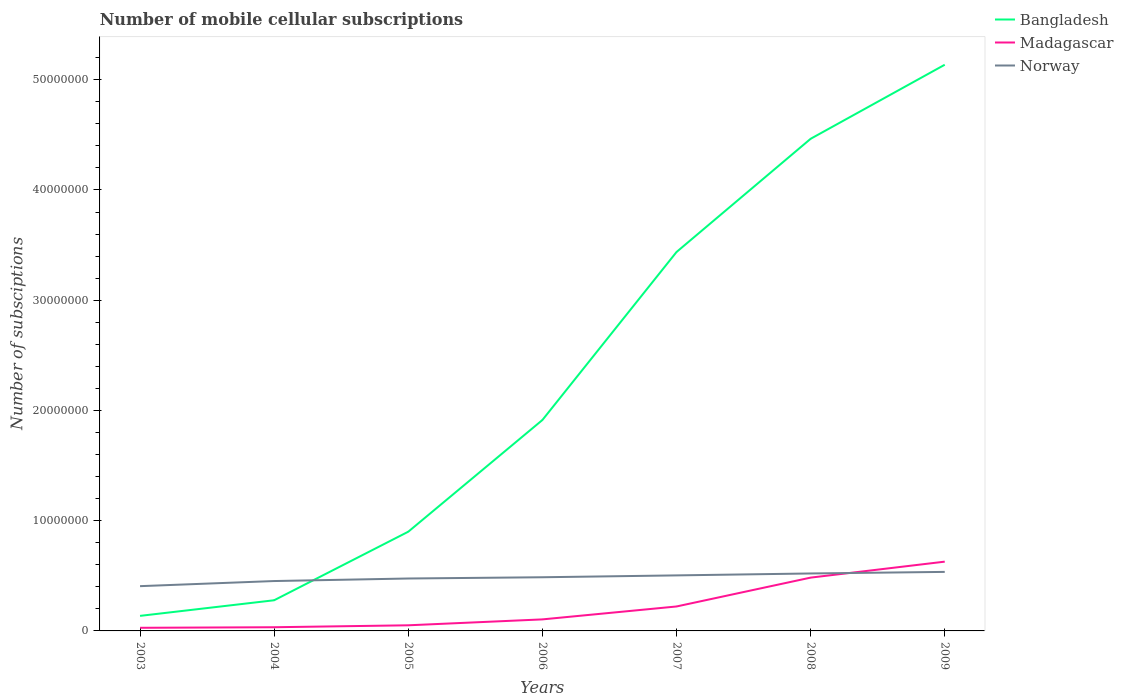Across all years, what is the maximum number of mobile cellular subscriptions in Madagascar?
Give a very brief answer. 2.84e+05. In which year was the number of mobile cellular subscriptions in Norway maximum?
Your response must be concise. 2003. What is the total number of mobile cellular subscriptions in Norway in the graph?
Provide a short and direct response. -4.86e+05. What is the difference between the highest and the second highest number of mobile cellular subscriptions in Madagascar?
Your response must be concise. 6.00e+06. What is the difference between the highest and the lowest number of mobile cellular subscriptions in Bangladesh?
Your answer should be very brief. 3. Is the number of mobile cellular subscriptions in Madagascar strictly greater than the number of mobile cellular subscriptions in Norway over the years?
Make the answer very short. No. How many years are there in the graph?
Give a very brief answer. 7. What is the difference between two consecutive major ticks on the Y-axis?
Your answer should be very brief. 1.00e+07. Does the graph contain any zero values?
Offer a very short reply. No. How are the legend labels stacked?
Ensure brevity in your answer.  Vertical. What is the title of the graph?
Your answer should be very brief. Number of mobile cellular subscriptions. What is the label or title of the X-axis?
Offer a terse response. Years. What is the label or title of the Y-axis?
Provide a short and direct response. Number of subsciptions. What is the Number of subsciptions in Bangladesh in 2003?
Your response must be concise. 1.36e+06. What is the Number of subsciptions of Madagascar in 2003?
Your response must be concise. 2.84e+05. What is the Number of subsciptions in Norway in 2003?
Your answer should be very brief. 4.06e+06. What is the Number of subsciptions of Bangladesh in 2004?
Provide a short and direct response. 2.78e+06. What is the Number of subsciptions in Madagascar in 2004?
Your response must be concise. 3.34e+05. What is the Number of subsciptions of Norway in 2004?
Offer a very short reply. 4.52e+06. What is the Number of subsciptions in Bangladesh in 2005?
Offer a terse response. 9.00e+06. What is the Number of subsciptions of Madagascar in 2005?
Offer a terse response. 5.10e+05. What is the Number of subsciptions of Norway in 2005?
Offer a terse response. 4.75e+06. What is the Number of subsciptions in Bangladesh in 2006?
Provide a succinct answer. 1.91e+07. What is the Number of subsciptions of Madagascar in 2006?
Your response must be concise. 1.05e+06. What is the Number of subsciptions of Norway in 2006?
Your answer should be compact. 4.87e+06. What is the Number of subsciptions in Bangladesh in 2007?
Give a very brief answer. 3.44e+07. What is the Number of subsciptions in Madagascar in 2007?
Your answer should be very brief. 2.22e+06. What is the Number of subsciptions in Norway in 2007?
Provide a succinct answer. 5.04e+06. What is the Number of subsciptions in Bangladesh in 2008?
Offer a very short reply. 4.46e+07. What is the Number of subsciptions of Madagascar in 2008?
Offer a very short reply. 4.84e+06. What is the Number of subsciptions of Norway in 2008?
Offer a terse response. 5.21e+06. What is the Number of subsciptions of Bangladesh in 2009?
Make the answer very short. 5.14e+07. What is the Number of subsciptions of Madagascar in 2009?
Ensure brevity in your answer.  6.28e+06. What is the Number of subsciptions in Norway in 2009?
Keep it short and to the point. 5.35e+06. Across all years, what is the maximum Number of subsciptions of Bangladesh?
Your response must be concise. 5.14e+07. Across all years, what is the maximum Number of subsciptions in Madagascar?
Keep it short and to the point. 6.28e+06. Across all years, what is the maximum Number of subsciptions of Norway?
Make the answer very short. 5.35e+06. Across all years, what is the minimum Number of subsciptions of Bangladesh?
Offer a very short reply. 1.36e+06. Across all years, what is the minimum Number of subsciptions in Madagascar?
Keep it short and to the point. 2.84e+05. Across all years, what is the minimum Number of subsciptions of Norway?
Your answer should be very brief. 4.06e+06. What is the total Number of subsciptions in Bangladesh in the graph?
Provide a short and direct response. 1.63e+08. What is the total Number of subsciptions of Madagascar in the graph?
Make the answer very short. 1.55e+07. What is the total Number of subsciptions in Norway in the graph?
Offer a terse response. 3.38e+07. What is the difference between the Number of subsciptions of Bangladesh in 2003 and that in 2004?
Keep it short and to the point. -1.42e+06. What is the difference between the Number of subsciptions of Madagascar in 2003 and that in 2004?
Offer a very short reply. -5.02e+04. What is the difference between the Number of subsciptions in Norway in 2003 and that in 2004?
Provide a succinct answer. -4.64e+05. What is the difference between the Number of subsciptions of Bangladesh in 2003 and that in 2005?
Provide a short and direct response. -7.64e+06. What is the difference between the Number of subsciptions in Madagascar in 2003 and that in 2005?
Give a very brief answer. -2.27e+05. What is the difference between the Number of subsciptions in Norway in 2003 and that in 2005?
Keep it short and to the point. -6.94e+05. What is the difference between the Number of subsciptions of Bangladesh in 2003 and that in 2006?
Your answer should be compact. -1.78e+07. What is the difference between the Number of subsciptions in Madagascar in 2003 and that in 2006?
Your response must be concise. -7.62e+05. What is the difference between the Number of subsciptions in Norway in 2003 and that in 2006?
Offer a very short reply. -8.08e+05. What is the difference between the Number of subsciptions of Bangladesh in 2003 and that in 2007?
Your answer should be compact. -3.30e+07. What is the difference between the Number of subsciptions of Madagascar in 2003 and that in 2007?
Give a very brief answer. -1.93e+06. What is the difference between the Number of subsciptions of Norway in 2003 and that in 2007?
Your answer should be compact. -9.77e+05. What is the difference between the Number of subsciptions of Bangladesh in 2003 and that in 2008?
Keep it short and to the point. -4.33e+07. What is the difference between the Number of subsciptions in Madagascar in 2003 and that in 2008?
Offer a terse response. -4.55e+06. What is the difference between the Number of subsciptions in Norway in 2003 and that in 2008?
Provide a succinct answer. -1.15e+06. What is the difference between the Number of subsciptions of Bangladesh in 2003 and that in 2009?
Your answer should be very brief. -5.00e+07. What is the difference between the Number of subsciptions of Madagascar in 2003 and that in 2009?
Your answer should be very brief. -6.00e+06. What is the difference between the Number of subsciptions of Norway in 2003 and that in 2009?
Make the answer very short. -1.29e+06. What is the difference between the Number of subsciptions in Bangladesh in 2004 and that in 2005?
Offer a terse response. -6.22e+06. What is the difference between the Number of subsciptions of Madagascar in 2004 and that in 2005?
Provide a short and direct response. -1.76e+05. What is the difference between the Number of subsciptions in Norway in 2004 and that in 2005?
Offer a terse response. -2.30e+05. What is the difference between the Number of subsciptions in Bangladesh in 2004 and that in 2006?
Keep it short and to the point. -1.63e+07. What is the difference between the Number of subsciptions in Madagascar in 2004 and that in 2006?
Make the answer very short. -7.12e+05. What is the difference between the Number of subsciptions in Norway in 2004 and that in 2006?
Offer a very short reply. -3.44e+05. What is the difference between the Number of subsciptions in Bangladesh in 2004 and that in 2007?
Make the answer very short. -3.16e+07. What is the difference between the Number of subsciptions of Madagascar in 2004 and that in 2007?
Provide a succinct answer. -1.88e+06. What is the difference between the Number of subsciptions of Norway in 2004 and that in 2007?
Your response must be concise. -5.13e+05. What is the difference between the Number of subsciptions of Bangladesh in 2004 and that in 2008?
Your answer should be very brief. -4.19e+07. What is the difference between the Number of subsciptions of Madagascar in 2004 and that in 2008?
Your response must be concise. -4.50e+06. What is the difference between the Number of subsciptions in Norway in 2004 and that in 2008?
Make the answer very short. -6.86e+05. What is the difference between the Number of subsciptions in Bangladesh in 2004 and that in 2009?
Offer a terse response. -4.86e+07. What is the difference between the Number of subsciptions in Madagascar in 2004 and that in 2009?
Give a very brief answer. -5.95e+06. What is the difference between the Number of subsciptions in Norway in 2004 and that in 2009?
Provide a short and direct response. -8.30e+05. What is the difference between the Number of subsciptions in Bangladesh in 2005 and that in 2006?
Offer a very short reply. -1.01e+07. What is the difference between the Number of subsciptions of Madagascar in 2005 and that in 2006?
Keep it short and to the point. -5.36e+05. What is the difference between the Number of subsciptions of Norway in 2005 and that in 2006?
Your response must be concise. -1.14e+05. What is the difference between the Number of subsciptions of Bangladesh in 2005 and that in 2007?
Provide a short and direct response. -2.54e+07. What is the difference between the Number of subsciptions in Madagascar in 2005 and that in 2007?
Provide a short and direct response. -1.71e+06. What is the difference between the Number of subsciptions of Norway in 2005 and that in 2007?
Provide a short and direct response. -2.83e+05. What is the difference between the Number of subsciptions of Bangladesh in 2005 and that in 2008?
Offer a very short reply. -3.56e+07. What is the difference between the Number of subsciptions of Madagascar in 2005 and that in 2008?
Keep it short and to the point. -4.32e+06. What is the difference between the Number of subsciptions of Norway in 2005 and that in 2008?
Provide a short and direct response. -4.57e+05. What is the difference between the Number of subsciptions of Bangladesh in 2005 and that in 2009?
Provide a succinct answer. -4.24e+07. What is the difference between the Number of subsciptions of Madagascar in 2005 and that in 2009?
Your answer should be compact. -5.77e+06. What is the difference between the Number of subsciptions in Norway in 2005 and that in 2009?
Your response must be concise. -6.00e+05. What is the difference between the Number of subsciptions in Bangladesh in 2006 and that in 2007?
Give a very brief answer. -1.52e+07. What is the difference between the Number of subsciptions of Madagascar in 2006 and that in 2007?
Give a very brief answer. -1.17e+06. What is the difference between the Number of subsciptions of Norway in 2006 and that in 2007?
Provide a succinct answer. -1.69e+05. What is the difference between the Number of subsciptions of Bangladesh in 2006 and that in 2008?
Keep it short and to the point. -2.55e+07. What is the difference between the Number of subsciptions in Madagascar in 2006 and that in 2008?
Your answer should be very brief. -3.79e+06. What is the difference between the Number of subsciptions in Norway in 2006 and that in 2008?
Your answer should be very brief. -3.42e+05. What is the difference between the Number of subsciptions in Bangladesh in 2006 and that in 2009?
Provide a short and direct response. -3.22e+07. What is the difference between the Number of subsciptions of Madagascar in 2006 and that in 2009?
Provide a succinct answer. -5.24e+06. What is the difference between the Number of subsciptions of Norway in 2006 and that in 2009?
Keep it short and to the point. -4.86e+05. What is the difference between the Number of subsciptions of Bangladesh in 2007 and that in 2008?
Offer a very short reply. -1.03e+07. What is the difference between the Number of subsciptions of Madagascar in 2007 and that in 2008?
Provide a succinct answer. -2.62e+06. What is the difference between the Number of subsciptions of Norway in 2007 and that in 2008?
Your answer should be very brief. -1.74e+05. What is the difference between the Number of subsciptions of Bangladesh in 2007 and that in 2009?
Ensure brevity in your answer.  -1.70e+07. What is the difference between the Number of subsciptions of Madagascar in 2007 and that in 2009?
Provide a succinct answer. -4.07e+06. What is the difference between the Number of subsciptions in Norway in 2007 and that in 2009?
Ensure brevity in your answer.  -3.17e+05. What is the difference between the Number of subsciptions in Bangladesh in 2008 and that in 2009?
Ensure brevity in your answer.  -6.72e+06. What is the difference between the Number of subsciptions in Madagascar in 2008 and that in 2009?
Keep it short and to the point. -1.45e+06. What is the difference between the Number of subsciptions in Norway in 2008 and that in 2009?
Keep it short and to the point. -1.43e+05. What is the difference between the Number of subsciptions of Bangladesh in 2003 and the Number of subsciptions of Madagascar in 2004?
Make the answer very short. 1.03e+06. What is the difference between the Number of subsciptions of Bangladesh in 2003 and the Number of subsciptions of Norway in 2004?
Give a very brief answer. -3.16e+06. What is the difference between the Number of subsciptions of Madagascar in 2003 and the Number of subsciptions of Norway in 2004?
Give a very brief answer. -4.24e+06. What is the difference between the Number of subsciptions of Bangladesh in 2003 and the Number of subsciptions of Madagascar in 2005?
Your answer should be very brief. 8.55e+05. What is the difference between the Number of subsciptions in Bangladesh in 2003 and the Number of subsciptions in Norway in 2005?
Offer a terse response. -3.39e+06. What is the difference between the Number of subsciptions of Madagascar in 2003 and the Number of subsciptions of Norway in 2005?
Provide a short and direct response. -4.47e+06. What is the difference between the Number of subsciptions of Bangladesh in 2003 and the Number of subsciptions of Madagascar in 2006?
Ensure brevity in your answer.  3.19e+05. What is the difference between the Number of subsciptions of Bangladesh in 2003 and the Number of subsciptions of Norway in 2006?
Your response must be concise. -3.50e+06. What is the difference between the Number of subsciptions of Madagascar in 2003 and the Number of subsciptions of Norway in 2006?
Provide a succinct answer. -4.59e+06. What is the difference between the Number of subsciptions of Bangladesh in 2003 and the Number of subsciptions of Madagascar in 2007?
Offer a terse response. -8.53e+05. What is the difference between the Number of subsciptions in Bangladesh in 2003 and the Number of subsciptions in Norway in 2007?
Give a very brief answer. -3.67e+06. What is the difference between the Number of subsciptions in Madagascar in 2003 and the Number of subsciptions in Norway in 2007?
Your answer should be very brief. -4.75e+06. What is the difference between the Number of subsciptions of Bangladesh in 2003 and the Number of subsciptions of Madagascar in 2008?
Offer a terse response. -3.47e+06. What is the difference between the Number of subsciptions in Bangladesh in 2003 and the Number of subsciptions in Norway in 2008?
Offer a very short reply. -3.85e+06. What is the difference between the Number of subsciptions in Madagascar in 2003 and the Number of subsciptions in Norway in 2008?
Keep it short and to the point. -4.93e+06. What is the difference between the Number of subsciptions of Bangladesh in 2003 and the Number of subsciptions of Madagascar in 2009?
Offer a very short reply. -4.92e+06. What is the difference between the Number of subsciptions in Bangladesh in 2003 and the Number of subsciptions in Norway in 2009?
Ensure brevity in your answer.  -3.99e+06. What is the difference between the Number of subsciptions in Madagascar in 2003 and the Number of subsciptions in Norway in 2009?
Give a very brief answer. -5.07e+06. What is the difference between the Number of subsciptions of Bangladesh in 2004 and the Number of subsciptions of Madagascar in 2005?
Provide a succinct answer. 2.27e+06. What is the difference between the Number of subsciptions in Bangladesh in 2004 and the Number of subsciptions in Norway in 2005?
Keep it short and to the point. -1.97e+06. What is the difference between the Number of subsciptions of Madagascar in 2004 and the Number of subsciptions of Norway in 2005?
Make the answer very short. -4.42e+06. What is the difference between the Number of subsciptions of Bangladesh in 2004 and the Number of subsciptions of Madagascar in 2006?
Ensure brevity in your answer.  1.74e+06. What is the difference between the Number of subsciptions of Bangladesh in 2004 and the Number of subsciptions of Norway in 2006?
Your answer should be very brief. -2.09e+06. What is the difference between the Number of subsciptions of Madagascar in 2004 and the Number of subsciptions of Norway in 2006?
Your answer should be compact. -4.54e+06. What is the difference between the Number of subsciptions of Bangladesh in 2004 and the Number of subsciptions of Madagascar in 2007?
Offer a terse response. 5.64e+05. What is the difference between the Number of subsciptions in Bangladesh in 2004 and the Number of subsciptions in Norway in 2007?
Give a very brief answer. -2.26e+06. What is the difference between the Number of subsciptions in Madagascar in 2004 and the Number of subsciptions in Norway in 2007?
Provide a short and direct response. -4.70e+06. What is the difference between the Number of subsciptions of Bangladesh in 2004 and the Number of subsciptions of Madagascar in 2008?
Your response must be concise. -2.05e+06. What is the difference between the Number of subsciptions of Bangladesh in 2004 and the Number of subsciptions of Norway in 2008?
Provide a short and direct response. -2.43e+06. What is the difference between the Number of subsciptions of Madagascar in 2004 and the Number of subsciptions of Norway in 2008?
Offer a very short reply. -4.88e+06. What is the difference between the Number of subsciptions in Bangladesh in 2004 and the Number of subsciptions in Madagascar in 2009?
Make the answer very short. -3.50e+06. What is the difference between the Number of subsciptions in Bangladesh in 2004 and the Number of subsciptions in Norway in 2009?
Ensure brevity in your answer.  -2.57e+06. What is the difference between the Number of subsciptions in Madagascar in 2004 and the Number of subsciptions in Norway in 2009?
Provide a short and direct response. -5.02e+06. What is the difference between the Number of subsciptions in Bangladesh in 2005 and the Number of subsciptions in Madagascar in 2006?
Keep it short and to the point. 7.95e+06. What is the difference between the Number of subsciptions of Bangladesh in 2005 and the Number of subsciptions of Norway in 2006?
Provide a succinct answer. 4.13e+06. What is the difference between the Number of subsciptions in Madagascar in 2005 and the Number of subsciptions in Norway in 2006?
Offer a very short reply. -4.36e+06. What is the difference between the Number of subsciptions in Bangladesh in 2005 and the Number of subsciptions in Madagascar in 2007?
Offer a very short reply. 6.78e+06. What is the difference between the Number of subsciptions in Bangladesh in 2005 and the Number of subsciptions in Norway in 2007?
Offer a very short reply. 3.96e+06. What is the difference between the Number of subsciptions in Madagascar in 2005 and the Number of subsciptions in Norway in 2007?
Offer a terse response. -4.53e+06. What is the difference between the Number of subsciptions in Bangladesh in 2005 and the Number of subsciptions in Madagascar in 2008?
Make the answer very short. 4.16e+06. What is the difference between the Number of subsciptions of Bangladesh in 2005 and the Number of subsciptions of Norway in 2008?
Offer a very short reply. 3.79e+06. What is the difference between the Number of subsciptions of Madagascar in 2005 and the Number of subsciptions of Norway in 2008?
Keep it short and to the point. -4.70e+06. What is the difference between the Number of subsciptions of Bangladesh in 2005 and the Number of subsciptions of Madagascar in 2009?
Keep it short and to the point. 2.72e+06. What is the difference between the Number of subsciptions of Bangladesh in 2005 and the Number of subsciptions of Norway in 2009?
Make the answer very short. 3.65e+06. What is the difference between the Number of subsciptions of Madagascar in 2005 and the Number of subsciptions of Norway in 2009?
Ensure brevity in your answer.  -4.84e+06. What is the difference between the Number of subsciptions in Bangladesh in 2006 and the Number of subsciptions in Madagascar in 2007?
Offer a terse response. 1.69e+07. What is the difference between the Number of subsciptions in Bangladesh in 2006 and the Number of subsciptions in Norway in 2007?
Ensure brevity in your answer.  1.41e+07. What is the difference between the Number of subsciptions of Madagascar in 2006 and the Number of subsciptions of Norway in 2007?
Keep it short and to the point. -3.99e+06. What is the difference between the Number of subsciptions of Bangladesh in 2006 and the Number of subsciptions of Madagascar in 2008?
Make the answer very short. 1.43e+07. What is the difference between the Number of subsciptions of Bangladesh in 2006 and the Number of subsciptions of Norway in 2008?
Your answer should be compact. 1.39e+07. What is the difference between the Number of subsciptions of Madagascar in 2006 and the Number of subsciptions of Norway in 2008?
Offer a very short reply. -4.17e+06. What is the difference between the Number of subsciptions of Bangladesh in 2006 and the Number of subsciptions of Madagascar in 2009?
Offer a terse response. 1.28e+07. What is the difference between the Number of subsciptions in Bangladesh in 2006 and the Number of subsciptions in Norway in 2009?
Give a very brief answer. 1.38e+07. What is the difference between the Number of subsciptions of Madagascar in 2006 and the Number of subsciptions of Norway in 2009?
Make the answer very short. -4.31e+06. What is the difference between the Number of subsciptions of Bangladesh in 2007 and the Number of subsciptions of Madagascar in 2008?
Provide a short and direct response. 2.95e+07. What is the difference between the Number of subsciptions in Bangladesh in 2007 and the Number of subsciptions in Norway in 2008?
Your response must be concise. 2.92e+07. What is the difference between the Number of subsciptions of Madagascar in 2007 and the Number of subsciptions of Norway in 2008?
Make the answer very short. -2.99e+06. What is the difference between the Number of subsciptions in Bangladesh in 2007 and the Number of subsciptions in Madagascar in 2009?
Provide a short and direct response. 2.81e+07. What is the difference between the Number of subsciptions of Bangladesh in 2007 and the Number of subsciptions of Norway in 2009?
Offer a terse response. 2.90e+07. What is the difference between the Number of subsciptions of Madagascar in 2007 and the Number of subsciptions of Norway in 2009?
Make the answer very short. -3.14e+06. What is the difference between the Number of subsciptions in Bangladesh in 2008 and the Number of subsciptions in Madagascar in 2009?
Provide a short and direct response. 3.84e+07. What is the difference between the Number of subsciptions in Bangladesh in 2008 and the Number of subsciptions in Norway in 2009?
Your response must be concise. 3.93e+07. What is the difference between the Number of subsciptions of Madagascar in 2008 and the Number of subsciptions of Norway in 2009?
Your answer should be very brief. -5.19e+05. What is the average Number of subsciptions in Bangladesh per year?
Make the answer very short. 2.32e+07. What is the average Number of subsciptions of Madagascar per year?
Your response must be concise. 2.22e+06. What is the average Number of subsciptions of Norway per year?
Keep it short and to the point. 4.83e+06. In the year 2003, what is the difference between the Number of subsciptions in Bangladesh and Number of subsciptions in Madagascar?
Your response must be concise. 1.08e+06. In the year 2003, what is the difference between the Number of subsciptions of Bangladesh and Number of subsciptions of Norway?
Your response must be concise. -2.70e+06. In the year 2003, what is the difference between the Number of subsciptions in Madagascar and Number of subsciptions in Norway?
Keep it short and to the point. -3.78e+06. In the year 2004, what is the difference between the Number of subsciptions in Bangladesh and Number of subsciptions in Madagascar?
Offer a terse response. 2.45e+06. In the year 2004, what is the difference between the Number of subsciptions of Bangladesh and Number of subsciptions of Norway?
Provide a short and direct response. -1.74e+06. In the year 2004, what is the difference between the Number of subsciptions in Madagascar and Number of subsciptions in Norway?
Offer a terse response. -4.19e+06. In the year 2005, what is the difference between the Number of subsciptions of Bangladesh and Number of subsciptions of Madagascar?
Your response must be concise. 8.49e+06. In the year 2005, what is the difference between the Number of subsciptions of Bangladesh and Number of subsciptions of Norway?
Your response must be concise. 4.25e+06. In the year 2005, what is the difference between the Number of subsciptions of Madagascar and Number of subsciptions of Norway?
Keep it short and to the point. -4.24e+06. In the year 2006, what is the difference between the Number of subsciptions of Bangladesh and Number of subsciptions of Madagascar?
Your answer should be very brief. 1.81e+07. In the year 2006, what is the difference between the Number of subsciptions of Bangladesh and Number of subsciptions of Norway?
Make the answer very short. 1.43e+07. In the year 2006, what is the difference between the Number of subsciptions of Madagascar and Number of subsciptions of Norway?
Ensure brevity in your answer.  -3.82e+06. In the year 2007, what is the difference between the Number of subsciptions of Bangladesh and Number of subsciptions of Madagascar?
Give a very brief answer. 3.22e+07. In the year 2007, what is the difference between the Number of subsciptions of Bangladesh and Number of subsciptions of Norway?
Give a very brief answer. 2.93e+07. In the year 2007, what is the difference between the Number of subsciptions of Madagascar and Number of subsciptions of Norway?
Your answer should be very brief. -2.82e+06. In the year 2008, what is the difference between the Number of subsciptions of Bangladesh and Number of subsciptions of Madagascar?
Offer a very short reply. 3.98e+07. In the year 2008, what is the difference between the Number of subsciptions in Bangladesh and Number of subsciptions in Norway?
Keep it short and to the point. 3.94e+07. In the year 2008, what is the difference between the Number of subsciptions in Madagascar and Number of subsciptions in Norway?
Your answer should be very brief. -3.76e+05. In the year 2009, what is the difference between the Number of subsciptions in Bangladesh and Number of subsciptions in Madagascar?
Make the answer very short. 4.51e+07. In the year 2009, what is the difference between the Number of subsciptions of Bangladesh and Number of subsciptions of Norway?
Provide a succinct answer. 4.60e+07. In the year 2009, what is the difference between the Number of subsciptions of Madagascar and Number of subsciptions of Norway?
Provide a short and direct response. 9.29e+05. What is the ratio of the Number of subsciptions in Bangladesh in 2003 to that in 2004?
Your response must be concise. 0.49. What is the ratio of the Number of subsciptions of Madagascar in 2003 to that in 2004?
Give a very brief answer. 0.85. What is the ratio of the Number of subsciptions of Norway in 2003 to that in 2004?
Ensure brevity in your answer.  0.9. What is the ratio of the Number of subsciptions in Bangladesh in 2003 to that in 2005?
Offer a very short reply. 0.15. What is the ratio of the Number of subsciptions of Madagascar in 2003 to that in 2005?
Your answer should be very brief. 0.56. What is the ratio of the Number of subsciptions in Norway in 2003 to that in 2005?
Provide a short and direct response. 0.85. What is the ratio of the Number of subsciptions of Bangladesh in 2003 to that in 2006?
Give a very brief answer. 0.07. What is the ratio of the Number of subsciptions in Madagascar in 2003 to that in 2006?
Provide a short and direct response. 0.27. What is the ratio of the Number of subsciptions in Norway in 2003 to that in 2006?
Give a very brief answer. 0.83. What is the ratio of the Number of subsciptions of Bangladesh in 2003 to that in 2007?
Your answer should be compact. 0.04. What is the ratio of the Number of subsciptions in Madagascar in 2003 to that in 2007?
Offer a terse response. 0.13. What is the ratio of the Number of subsciptions of Norway in 2003 to that in 2007?
Give a very brief answer. 0.81. What is the ratio of the Number of subsciptions of Bangladesh in 2003 to that in 2008?
Provide a short and direct response. 0.03. What is the ratio of the Number of subsciptions of Madagascar in 2003 to that in 2008?
Provide a succinct answer. 0.06. What is the ratio of the Number of subsciptions in Norway in 2003 to that in 2008?
Offer a very short reply. 0.78. What is the ratio of the Number of subsciptions in Bangladesh in 2003 to that in 2009?
Offer a very short reply. 0.03. What is the ratio of the Number of subsciptions of Madagascar in 2003 to that in 2009?
Your answer should be very brief. 0.05. What is the ratio of the Number of subsciptions in Norway in 2003 to that in 2009?
Your answer should be compact. 0.76. What is the ratio of the Number of subsciptions in Bangladesh in 2004 to that in 2005?
Give a very brief answer. 0.31. What is the ratio of the Number of subsciptions in Madagascar in 2004 to that in 2005?
Make the answer very short. 0.65. What is the ratio of the Number of subsciptions of Norway in 2004 to that in 2005?
Your response must be concise. 0.95. What is the ratio of the Number of subsciptions of Bangladesh in 2004 to that in 2006?
Keep it short and to the point. 0.15. What is the ratio of the Number of subsciptions in Madagascar in 2004 to that in 2006?
Your answer should be compact. 0.32. What is the ratio of the Number of subsciptions of Norway in 2004 to that in 2006?
Provide a succinct answer. 0.93. What is the ratio of the Number of subsciptions of Bangladesh in 2004 to that in 2007?
Make the answer very short. 0.08. What is the ratio of the Number of subsciptions in Madagascar in 2004 to that in 2007?
Your answer should be very brief. 0.15. What is the ratio of the Number of subsciptions in Norway in 2004 to that in 2007?
Your response must be concise. 0.9. What is the ratio of the Number of subsciptions in Bangladesh in 2004 to that in 2008?
Make the answer very short. 0.06. What is the ratio of the Number of subsciptions in Madagascar in 2004 to that in 2008?
Your answer should be very brief. 0.07. What is the ratio of the Number of subsciptions in Norway in 2004 to that in 2008?
Offer a very short reply. 0.87. What is the ratio of the Number of subsciptions in Bangladesh in 2004 to that in 2009?
Provide a succinct answer. 0.05. What is the ratio of the Number of subsciptions in Madagascar in 2004 to that in 2009?
Make the answer very short. 0.05. What is the ratio of the Number of subsciptions of Norway in 2004 to that in 2009?
Give a very brief answer. 0.84. What is the ratio of the Number of subsciptions of Bangladesh in 2005 to that in 2006?
Provide a succinct answer. 0.47. What is the ratio of the Number of subsciptions of Madagascar in 2005 to that in 2006?
Make the answer very short. 0.49. What is the ratio of the Number of subsciptions of Norway in 2005 to that in 2006?
Provide a succinct answer. 0.98. What is the ratio of the Number of subsciptions of Bangladesh in 2005 to that in 2007?
Your response must be concise. 0.26. What is the ratio of the Number of subsciptions in Madagascar in 2005 to that in 2007?
Your response must be concise. 0.23. What is the ratio of the Number of subsciptions of Norway in 2005 to that in 2007?
Make the answer very short. 0.94. What is the ratio of the Number of subsciptions in Bangladesh in 2005 to that in 2008?
Your answer should be very brief. 0.2. What is the ratio of the Number of subsciptions of Madagascar in 2005 to that in 2008?
Make the answer very short. 0.11. What is the ratio of the Number of subsciptions in Norway in 2005 to that in 2008?
Make the answer very short. 0.91. What is the ratio of the Number of subsciptions in Bangladesh in 2005 to that in 2009?
Provide a succinct answer. 0.18. What is the ratio of the Number of subsciptions in Madagascar in 2005 to that in 2009?
Offer a very short reply. 0.08. What is the ratio of the Number of subsciptions in Norway in 2005 to that in 2009?
Provide a short and direct response. 0.89. What is the ratio of the Number of subsciptions of Bangladesh in 2006 to that in 2007?
Make the answer very short. 0.56. What is the ratio of the Number of subsciptions in Madagascar in 2006 to that in 2007?
Give a very brief answer. 0.47. What is the ratio of the Number of subsciptions in Norway in 2006 to that in 2007?
Your response must be concise. 0.97. What is the ratio of the Number of subsciptions in Bangladesh in 2006 to that in 2008?
Ensure brevity in your answer.  0.43. What is the ratio of the Number of subsciptions of Madagascar in 2006 to that in 2008?
Your answer should be compact. 0.22. What is the ratio of the Number of subsciptions of Norway in 2006 to that in 2008?
Ensure brevity in your answer.  0.93. What is the ratio of the Number of subsciptions in Bangladesh in 2006 to that in 2009?
Offer a terse response. 0.37. What is the ratio of the Number of subsciptions in Madagascar in 2006 to that in 2009?
Offer a terse response. 0.17. What is the ratio of the Number of subsciptions of Norway in 2006 to that in 2009?
Your answer should be very brief. 0.91. What is the ratio of the Number of subsciptions in Bangladesh in 2007 to that in 2008?
Provide a short and direct response. 0.77. What is the ratio of the Number of subsciptions in Madagascar in 2007 to that in 2008?
Keep it short and to the point. 0.46. What is the ratio of the Number of subsciptions in Norway in 2007 to that in 2008?
Provide a succinct answer. 0.97. What is the ratio of the Number of subsciptions of Bangladesh in 2007 to that in 2009?
Ensure brevity in your answer.  0.67. What is the ratio of the Number of subsciptions of Madagascar in 2007 to that in 2009?
Your answer should be compact. 0.35. What is the ratio of the Number of subsciptions in Norway in 2007 to that in 2009?
Offer a terse response. 0.94. What is the ratio of the Number of subsciptions of Bangladesh in 2008 to that in 2009?
Make the answer very short. 0.87. What is the ratio of the Number of subsciptions of Madagascar in 2008 to that in 2009?
Your answer should be very brief. 0.77. What is the ratio of the Number of subsciptions in Norway in 2008 to that in 2009?
Give a very brief answer. 0.97. What is the difference between the highest and the second highest Number of subsciptions of Bangladesh?
Keep it short and to the point. 6.72e+06. What is the difference between the highest and the second highest Number of subsciptions in Madagascar?
Give a very brief answer. 1.45e+06. What is the difference between the highest and the second highest Number of subsciptions of Norway?
Make the answer very short. 1.43e+05. What is the difference between the highest and the lowest Number of subsciptions in Bangladesh?
Your answer should be compact. 5.00e+07. What is the difference between the highest and the lowest Number of subsciptions of Madagascar?
Provide a succinct answer. 6.00e+06. What is the difference between the highest and the lowest Number of subsciptions of Norway?
Offer a terse response. 1.29e+06. 